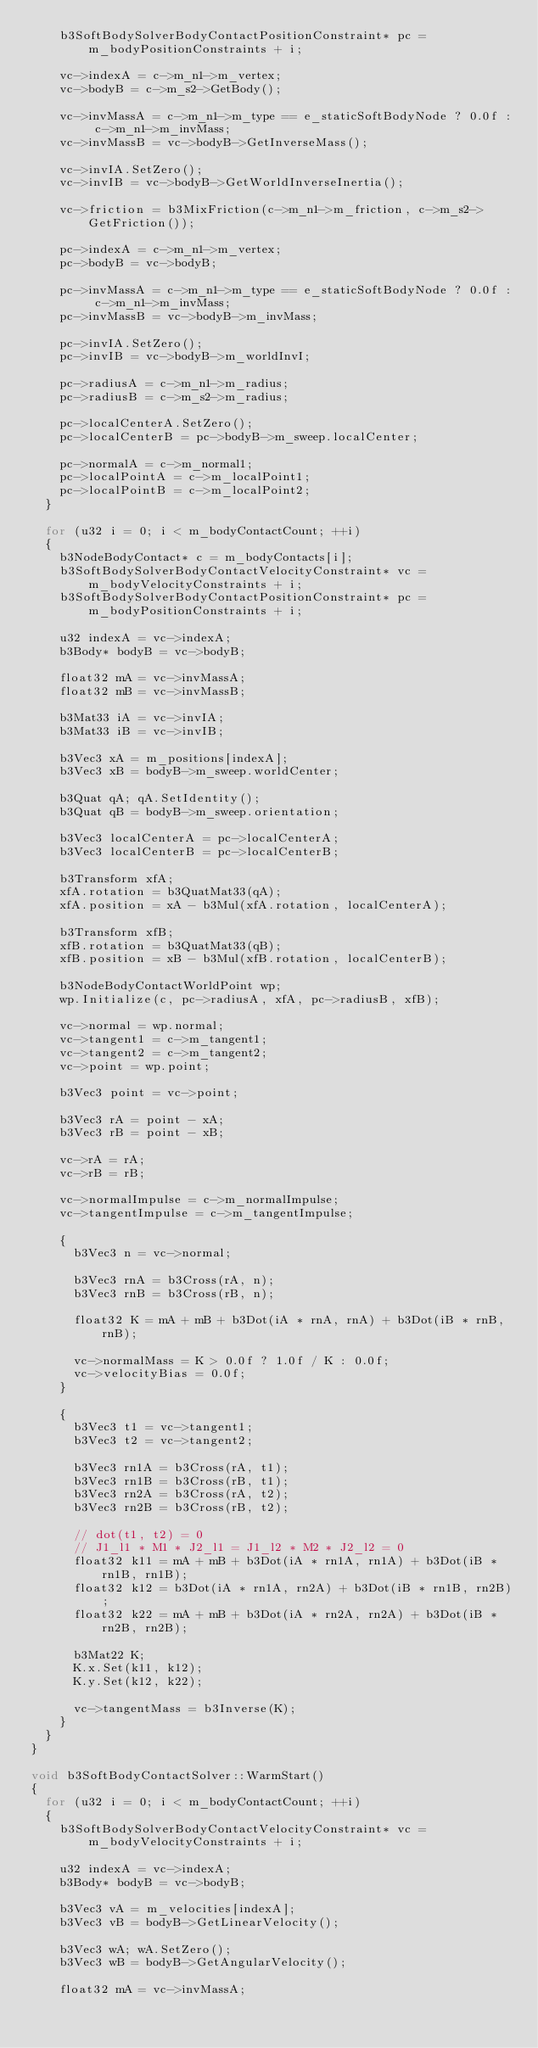Convert code to text. <code><loc_0><loc_0><loc_500><loc_500><_C++_>		b3SoftBodySolverBodyContactPositionConstraint* pc = m_bodyPositionConstraints + i;

		vc->indexA = c->m_n1->m_vertex;
		vc->bodyB = c->m_s2->GetBody();

		vc->invMassA = c->m_n1->m_type == e_staticSoftBodyNode ? 0.0f : c->m_n1->m_invMass;
		vc->invMassB = vc->bodyB->GetInverseMass();

		vc->invIA.SetZero();
		vc->invIB = vc->bodyB->GetWorldInverseInertia();

		vc->friction = b3MixFriction(c->m_n1->m_friction, c->m_s2->GetFriction());

		pc->indexA = c->m_n1->m_vertex;
		pc->bodyB = vc->bodyB;

		pc->invMassA = c->m_n1->m_type == e_staticSoftBodyNode ? 0.0f : c->m_n1->m_invMass;
		pc->invMassB = vc->bodyB->m_invMass;

		pc->invIA.SetZero();
		pc->invIB = vc->bodyB->m_worldInvI;

		pc->radiusA = c->m_n1->m_radius;
		pc->radiusB = c->m_s2->m_radius;

		pc->localCenterA.SetZero();
		pc->localCenterB = pc->bodyB->m_sweep.localCenter;

		pc->normalA = c->m_normal1;
		pc->localPointA = c->m_localPoint1;
		pc->localPointB = c->m_localPoint2;
	}

	for (u32 i = 0; i < m_bodyContactCount; ++i)
	{
		b3NodeBodyContact* c = m_bodyContacts[i];
		b3SoftBodySolverBodyContactVelocityConstraint* vc = m_bodyVelocityConstraints + i;
		b3SoftBodySolverBodyContactPositionConstraint* pc = m_bodyPositionConstraints + i;

		u32 indexA = vc->indexA;
		b3Body* bodyB = vc->bodyB;

		float32 mA = vc->invMassA;
		float32 mB = vc->invMassB;

		b3Mat33 iA = vc->invIA;
		b3Mat33 iB = vc->invIB;

		b3Vec3 xA = m_positions[indexA];
		b3Vec3 xB = bodyB->m_sweep.worldCenter;

		b3Quat qA; qA.SetIdentity();
		b3Quat qB = bodyB->m_sweep.orientation;

		b3Vec3 localCenterA = pc->localCenterA;
		b3Vec3 localCenterB = pc->localCenterB;

		b3Transform xfA;
		xfA.rotation = b3QuatMat33(qA);
		xfA.position = xA - b3Mul(xfA.rotation, localCenterA);

		b3Transform xfB;
		xfB.rotation = b3QuatMat33(qB);
		xfB.position = xB - b3Mul(xfB.rotation, localCenterB);

		b3NodeBodyContactWorldPoint wp;
		wp.Initialize(c, pc->radiusA, xfA, pc->radiusB, xfB);

		vc->normal = wp.normal;
		vc->tangent1 = c->m_tangent1;
		vc->tangent2 = c->m_tangent2;
		vc->point = wp.point;

		b3Vec3 point = vc->point;

		b3Vec3 rA = point - xA;
		b3Vec3 rB = point - xB;

		vc->rA = rA;
		vc->rB = rB;

		vc->normalImpulse = c->m_normalImpulse;
		vc->tangentImpulse = c->m_tangentImpulse;

		{
			b3Vec3 n = vc->normal;

			b3Vec3 rnA = b3Cross(rA, n);
			b3Vec3 rnB = b3Cross(rB, n);

			float32 K = mA + mB + b3Dot(iA * rnA, rnA) + b3Dot(iB * rnB, rnB);

			vc->normalMass = K > 0.0f ? 1.0f / K : 0.0f;
			vc->velocityBias = 0.0f;
		}

		{
			b3Vec3 t1 = vc->tangent1;
			b3Vec3 t2 = vc->tangent2;

			b3Vec3 rn1A = b3Cross(rA, t1);
			b3Vec3 rn1B = b3Cross(rB, t1);
			b3Vec3 rn2A = b3Cross(rA, t2);
			b3Vec3 rn2B = b3Cross(rB, t2);

			// dot(t1, t2) = 0
			// J1_l1 * M1 * J2_l1 = J1_l2 * M2 * J2_l2 = 0
			float32 k11 = mA + mB + b3Dot(iA * rn1A, rn1A) + b3Dot(iB * rn1B, rn1B);
			float32 k12 = b3Dot(iA * rn1A, rn2A) + b3Dot(iB * rn1B, rn2B);
			float32 k22 = mA + mB + b3Dot(iA * rn2A, rn2A) + b3Dot(iB * rn2B, rn2B);

			b3Mat22 K;
			K.x.Set(k11, k12);
			K.y.Set(k12, k22);

			vc->tangentMass = b3Inverse(K);
		}
	}
}

void b3SoftBodyContactSolver::WarmStart()
{
	for (u32 i = 0; i < m_bodyContactCount; ++i)
	{
		b3SoftBodySolverBodyContactVelocityConstraint* vc = m_bodyVelocityConstraints + i;

		u32 indexA = vc->indexA;
		b3Body* bodyB = vc->bodyB;

		b3Vec3 vA = m_velocities[indexA];
		b3Vec3 vB = bodyB->GetLinearVelocity();

		b3Vec3 wA; wA.SetZero();
		b3Vec3 wB = bodyB->GetAngularVelocity();

		float32 mA = vc->invMassA;</code> 